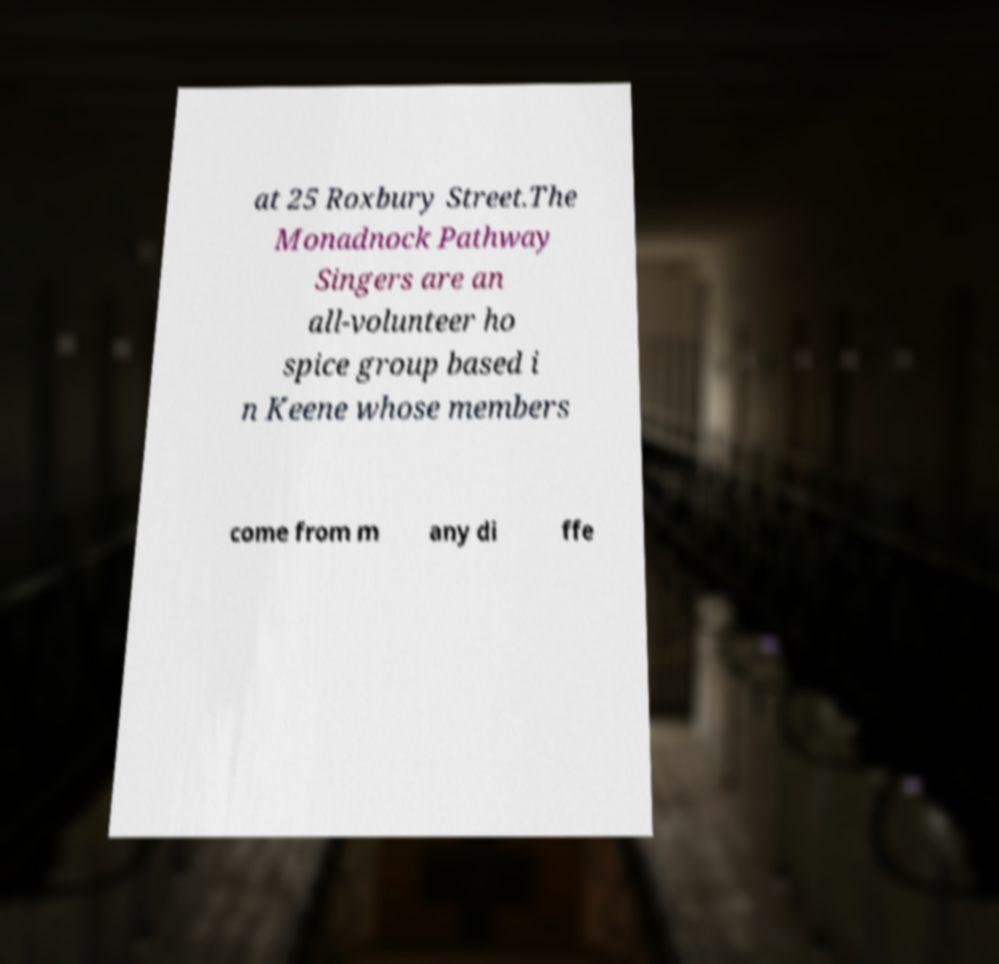Can you read and provide the text displayed in the image?This photo seems to have some interesting text. Can you extract and type it out for me? at 25 Roxbury Street.The Monadnock Pathway Singers are an all-volunteer ho spice group based i n Keene whose members come from m any di ffe 